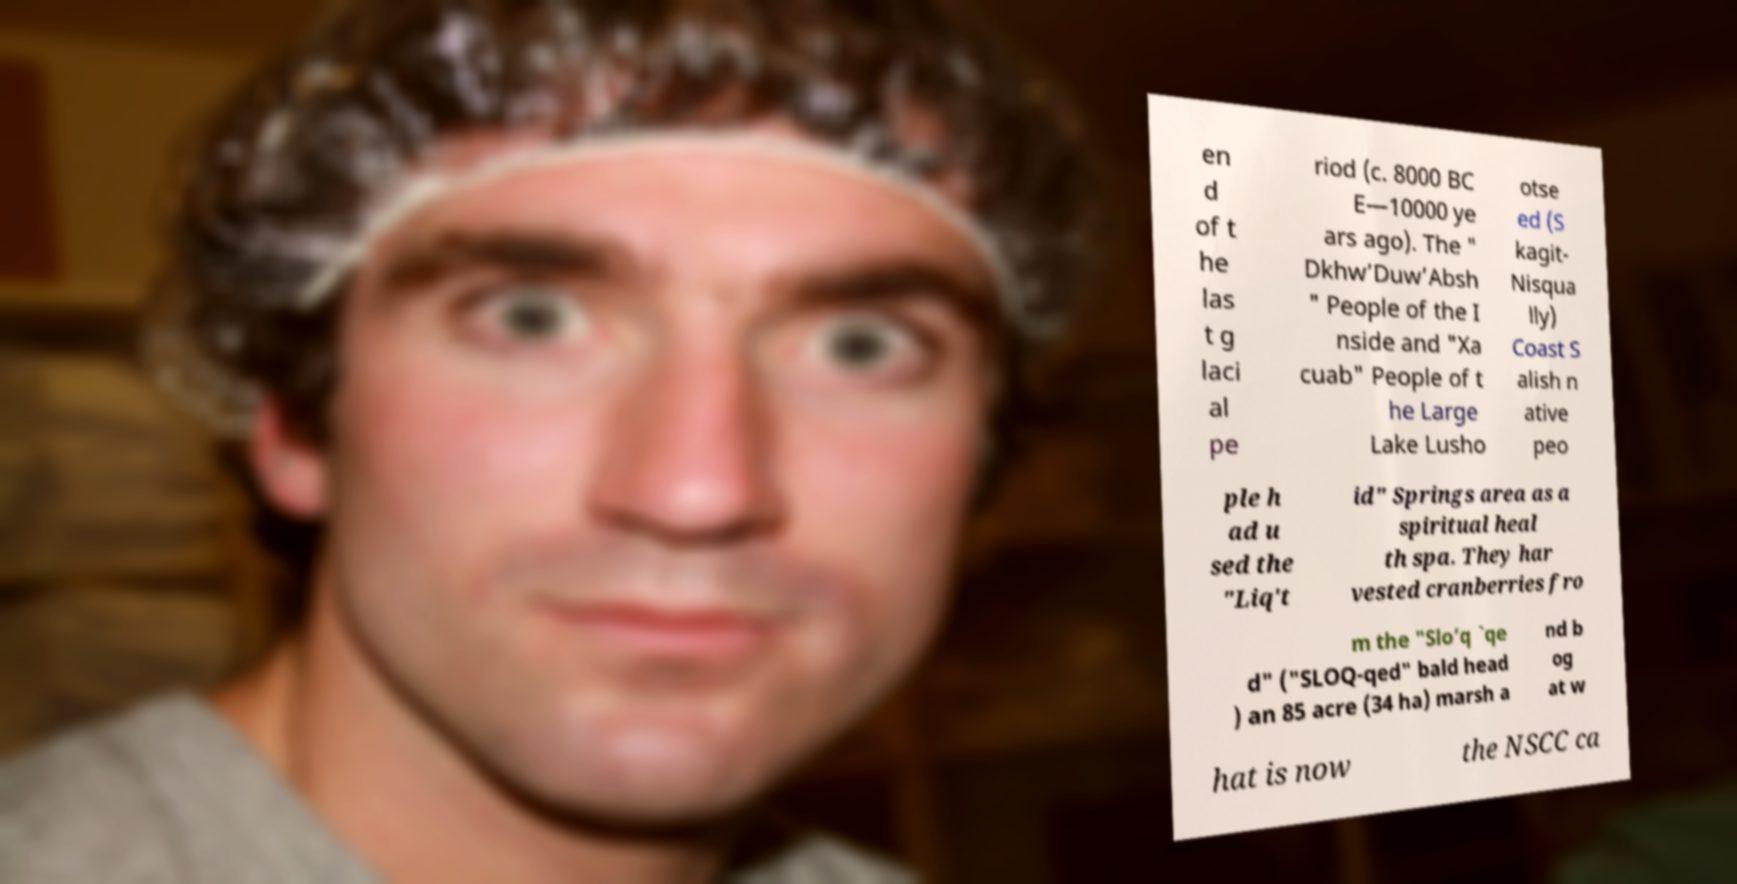I need the written content from this picture converted into text. Can you do that? en d of t he las t g laci al pe riod (c. 8000 BC E—10000 ye ars ago). The " Dkhw’Duw’Absh " People of the I nside and "Xa cuab" People of t he Large Lake Lusho otse ed (S kagit- Nisqua lly) Coast S alish n ative peo ple h ad u sed the "Liq't id" Springs area as a spiritual heal th spa. They har vested cranberries fro m the "Slo’q `qe d" ("SLOQ-qed" bald head ) an 85 acre (34 ha) marsh a nd b og at w hat is now the NSCC ca 